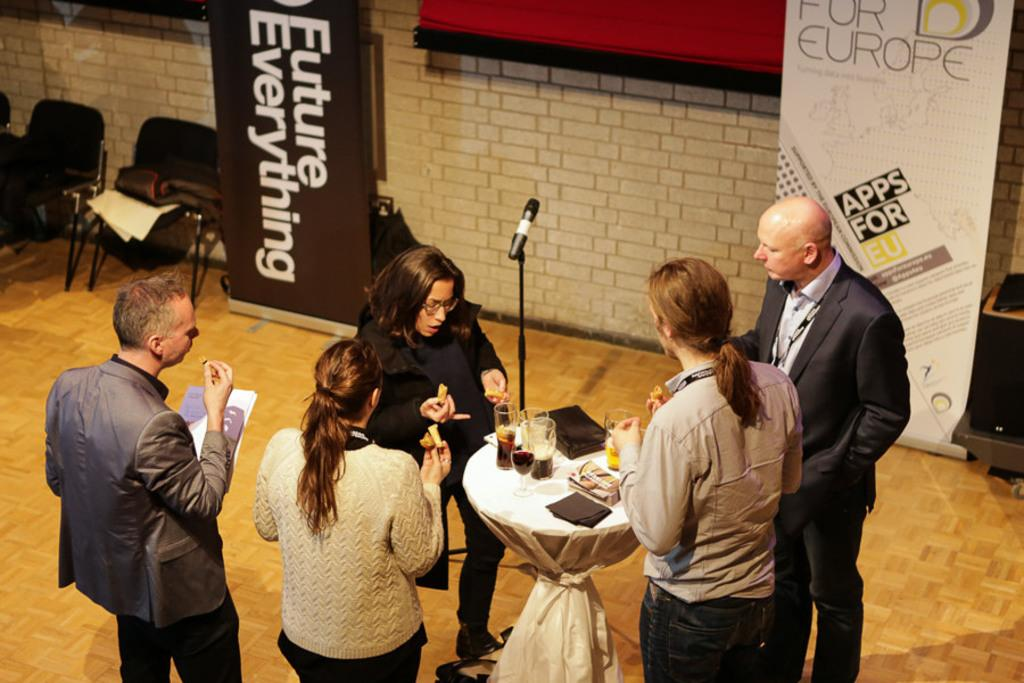What type of furniture can be seen in the image? There are chairs in the image. What decorative elements are present in the image? There are banners in the image. What type of structure is visible in the image? There is a building in the image. Can you describe the gathering of people in the image? There is a group of people in the image. What device is used for amplifying sound in the image? There is a microphone (mic) in the image. What type of surface is present in the image for placing objects? There is a table in the image. What is covering the table in the image? There is a white cloth on the table. What type of dishware is present on the table? There are glasses on the table. What type of owl can be seen perched on the microphone in the image? There is no owl present in the image; only the microphone and other mentioned objects are visible. What news event is being discussed by the group of people in the image? There is no indication of a news event or discussion in the image. What type of glue is being used to attach the banners to the building in the image? There is no glue or method of attachment mentioned or visible in the image. 